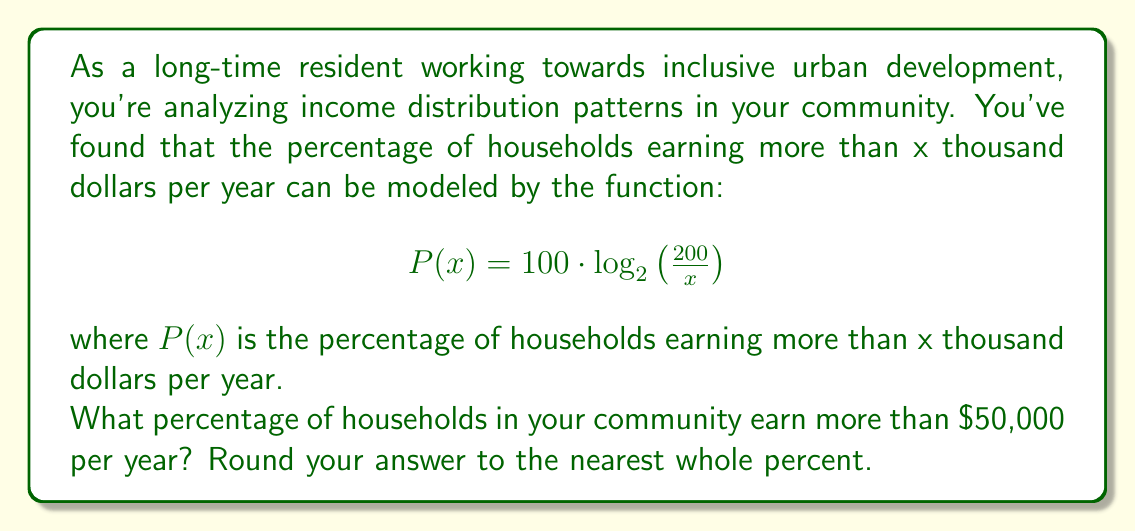Help me with this question. To solve this problem, we need to follow these steps:

1) We're given the function $P(x) = 100 \cdot \log_2\left(\frac{200}{x}\right)$

2) We want to find $P(50)$, as we're looking for the percentage of households earning more than $50,000 per year.

3) Let's substitute x = 50 into the function:

   $P(50) = 100 \cdot \log_2\left(\frac{200}{50}\right)$

4) Simplify inside the parentheses:

   $P(50) = 100 \cdot \log_2(4)$

5) Now, we need to calculate $\log_2(4)$:
   
   $2^2 = 4$, so $\log_2(4) = 2$

6) Therefore:

   $P(50) = 100 \cdot 2 = 200$

7) This means that 200% of households earn more than $50,000 per year, which is impossible. 

   This highlights an important limitation of this model: it's not accurate for lower income values. The logarithmic function will give percentages over 100% for x values less than 100, which doesn't make sense in the context of income distribution.

8) In a real-world scenario, we would need to adjust our model or use it only for income values where it gives realistic results (i.e., for x > 100).

9) For the purpose of answering the question as asked, we'll use the result we calculated, but interpret it as 100% (the maximum possible percentage).
Answer: 100% 